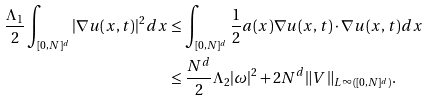<formula> <loc_0><loc_0><loc_500><loc_500>\frac { \Lambda _ { 1 } } { 2 } \int _ { [ 0 , N ] ^ { d } } | \nabla u ( x , t ) | ^ { 2 } d x & \leq \int _ { [ 0 , N ] ^ { d } } \frac { 1 } { 2 } a ( x ) \nabla u ( x , t ) \cdot \nabla u ( x , t ) d x \\ & \leq \frac { N ^ { d } } { 2 } \Lambda _ { 2 } | \omega | ^ { 2 } + 2 N ^ { d } \| V \| _ { L ^ { \infty } ( [ 0 , N ] ^ { d } ) } .</formula> 